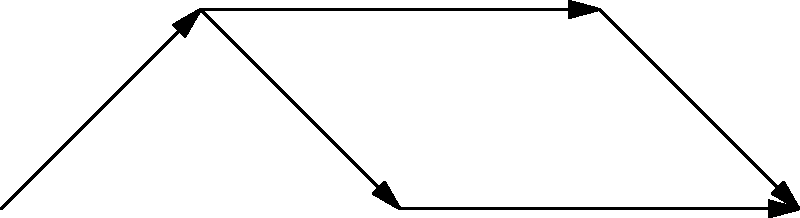Based on the network diagram illustrating the interconnected economic factors affected by carbon pricing policies, which factor serves as both an intermediate and final outcome in the effectiveness analysis of these policies? To answer this question, let's analyze the network diagram step-by-step:

1. The diagram shows five key factors: Carbon Price, Energy Costs, Industrial Output, Consumer Behavior, and GDP.

2. Carbon Price is the starting point, directly affecting Energy Costs.

3. Energy Costs, in turn, influence two factors:
   a) Industrial Output
   b) Consumer Behavior

4. Both Industrial Output and Consumer Behavior have arrows pointing to GDP.

5. There's also a dashed arrow directly from Carbon Price to GDP, indicating a potential direct relationship.

6. Looking at the flow of arrows, we can see that GDP is the final outcome in multiple pathways:
   a) Carbon Price → Energy Costs → Industrial Output → GDP
   b) Carbon Price → Energy Costs → Consumer Behavior → GDP
   c) Carbon Price → GDP (direct, dashed line)

7. However, GDP is not an intermediate factor, as it doesn't lead to any other outcomes in this diagram.

8. The factor that serves as both an intermediate and final outcome is Energy Costs:
   - It's an intermediate outcome of Carbon Price.
   - It leads to further outcomes (Industrial Output and Consumer Behavior).
   - It indirectly affects the final outcome (GDP) through these pathways.

Therefore, Energy Costs is the factor that serves as both an intermediate and final outcome in this effectiveness analysis of carbon pricing policies.
Answer: Energy Costs 